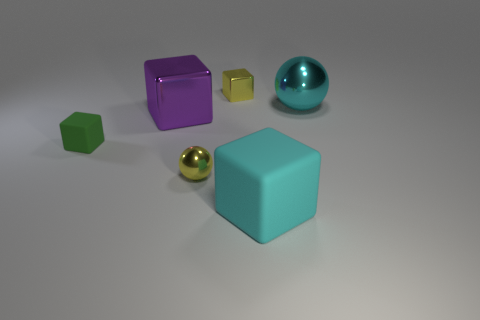Add 1 big blocks. How many objects exist? 7 Subtract all spheres. How many objects are left? 4 Subtract all cyan balls. Subtract all small shiny spheres. How many objects are left? 4 Add 6 big purple things. How many big purple things are left? 7 Add 3 rubber cylinders. How many rubber cylinders exist? 3 Subtract 1 yellow spheres. How many objects are left? 5 